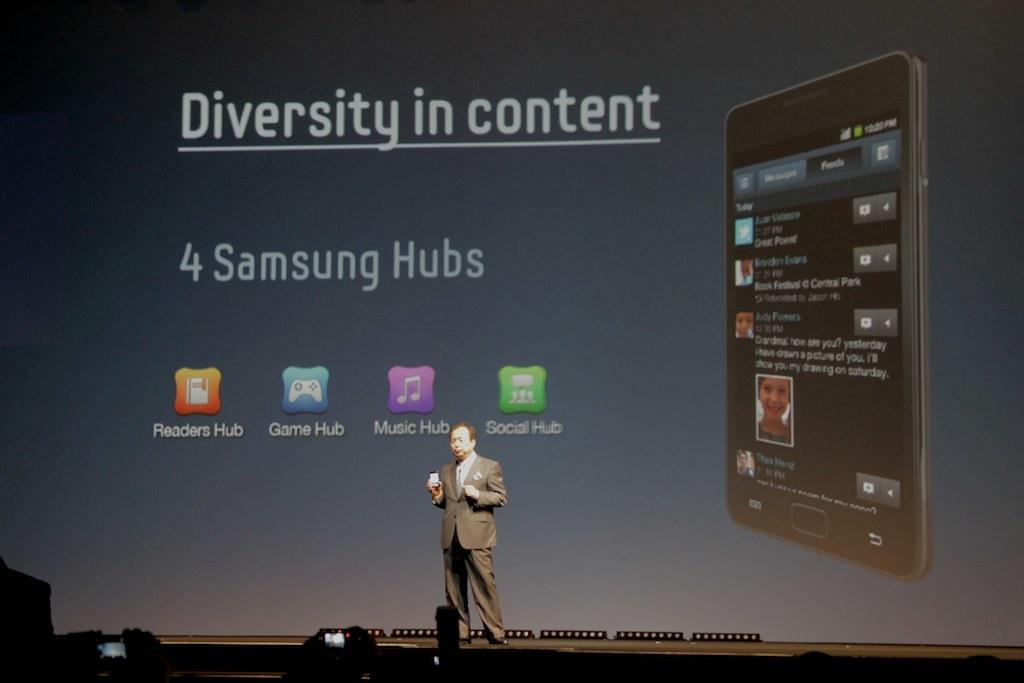<image>
Present a compact description of the photo's key features. man onstage with a phone and display behind him is for diversity in content and shows 4 samsung hubs 